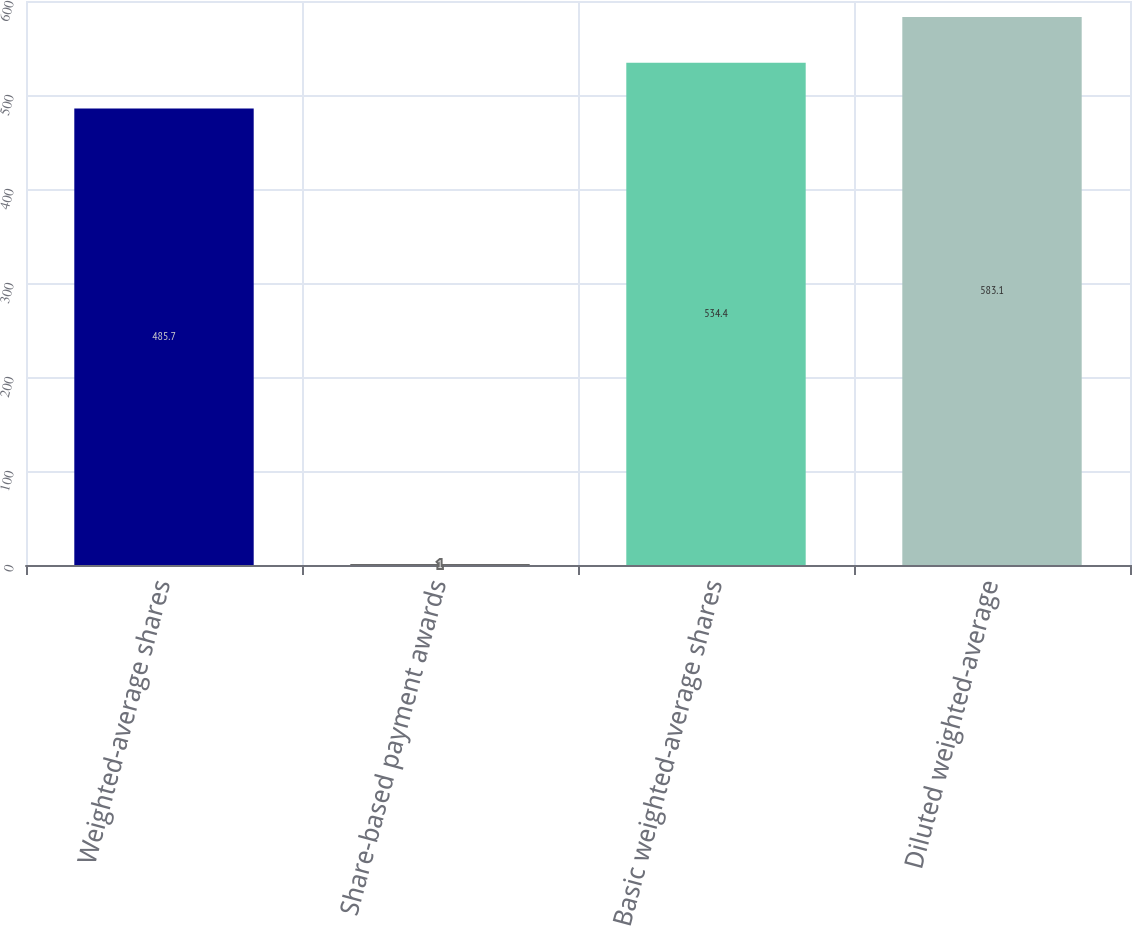<chart> <loc_0><loc_0><loc_500><loc_500><bar_chart><fcel>Weighted-average shares<fcel>Share-based payment awards<fcel>Basic weighted-average shares<fcel>Diluted weighted-average<nl><fcel>485.7<fcel>1<fcel>534.4<fcel>583.1<nl></chart> 